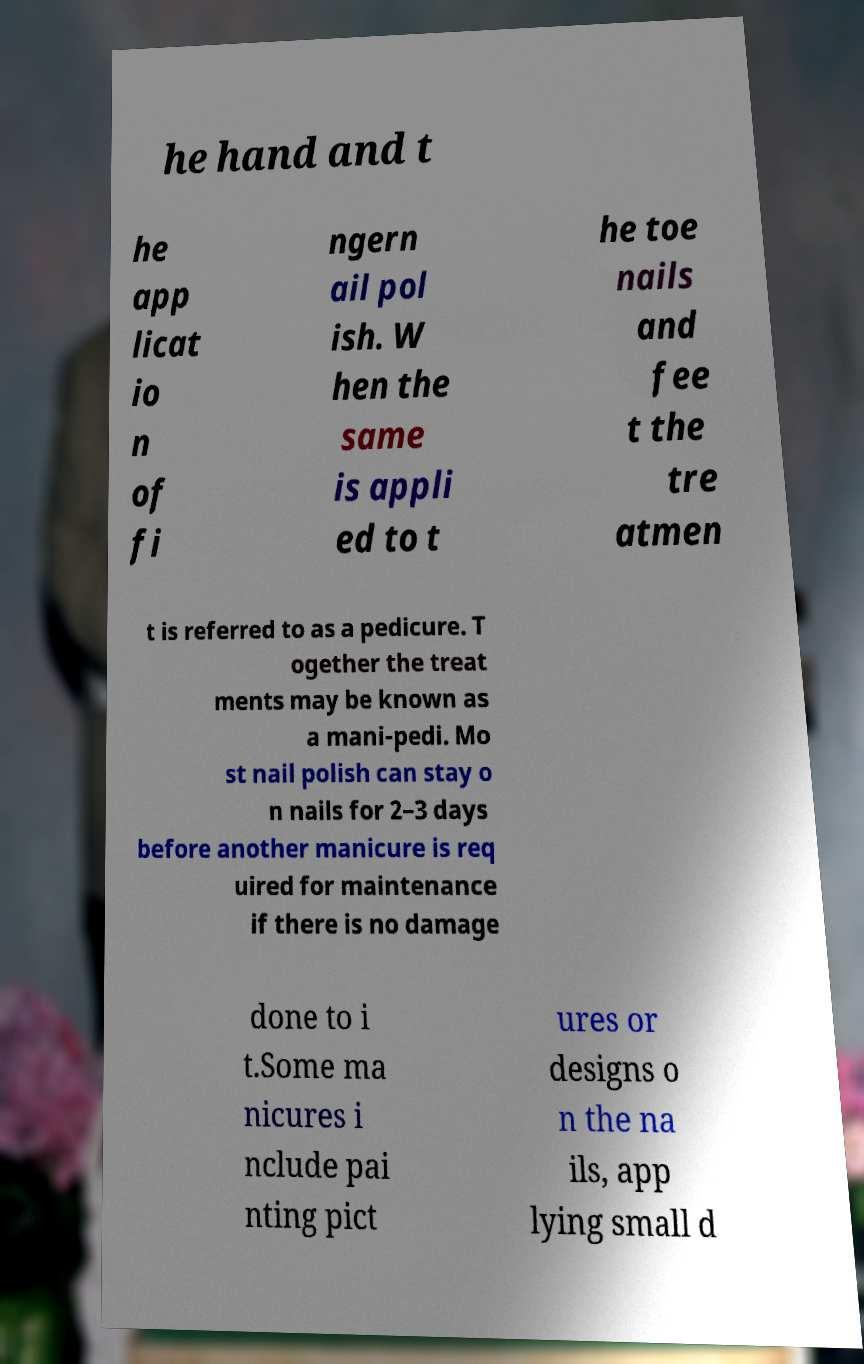There's text embedded in this image that I need extracted. Can you transcribe it verbatim? he hand and t he app licat io n of fi ngern ail pol ish. W hen the same is appli ed to t he toe nails and fee t the tre atmen t is referred to as a pedicure. T ogether the treat ments may be known as a mani-pedi. Mo st nail polish can stay o n nails for 2–3 days before another manicure is req uired for maintenance if there is no damage done to i t.Some ma nicures i nclude pai nting pict ures or designs o n the na ils, app lying small d 